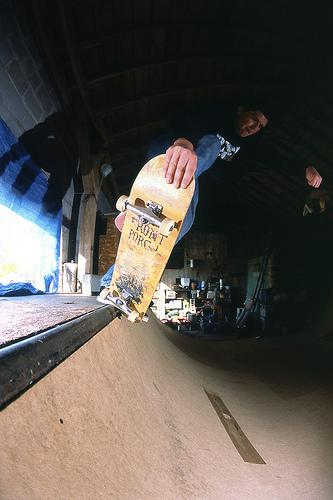Question: who has the skateboard?
Choices:
A. The guy.
B. The man.
C. The boy.
D. The skateboarder.
Answer with the letter. Answer: D Question: what has wheels?
Choices:
A. The bicycle.
B. The skateboard.
C. The car.
D. The cart.
Answer with the letter. Answer: B Question: when was the photo taken?
Choices:
A. While the skateboarder  was above ground.
B. While the skateboarder was up.
C. While the skateboarder was in the air.
D. While the skateboarder was flying.
Answer with the letter. Answer: C 